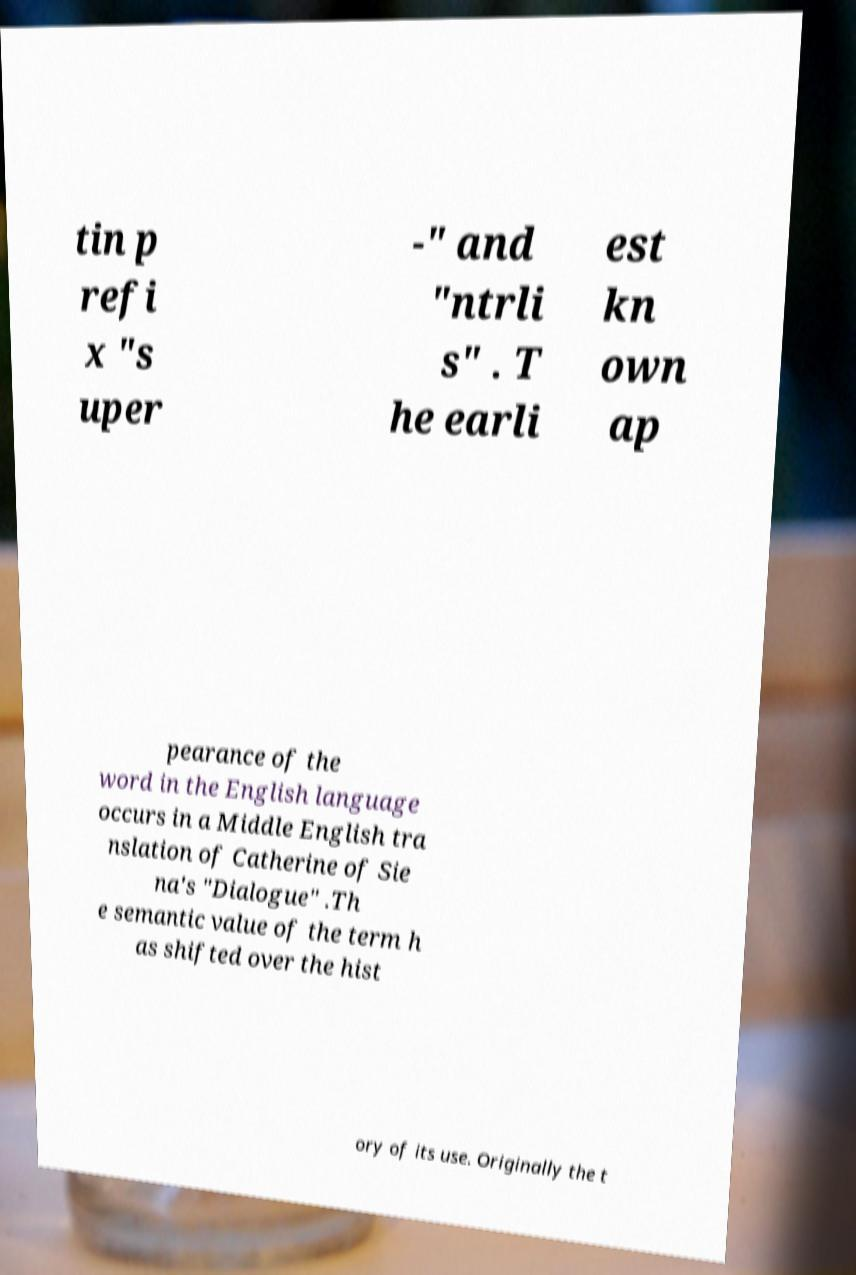Please read and relay the text visible in this image. What does it say? tin p refi x "s uper -" and "ntrli s" . T he earli est kn own ap pearance of the word in the English language occurs in a Middle English tra nslation of Catherine of Sie na's "Dialogue" .Th e semantic value of the term h as shifted over the hist ory of its use. Originally the t 